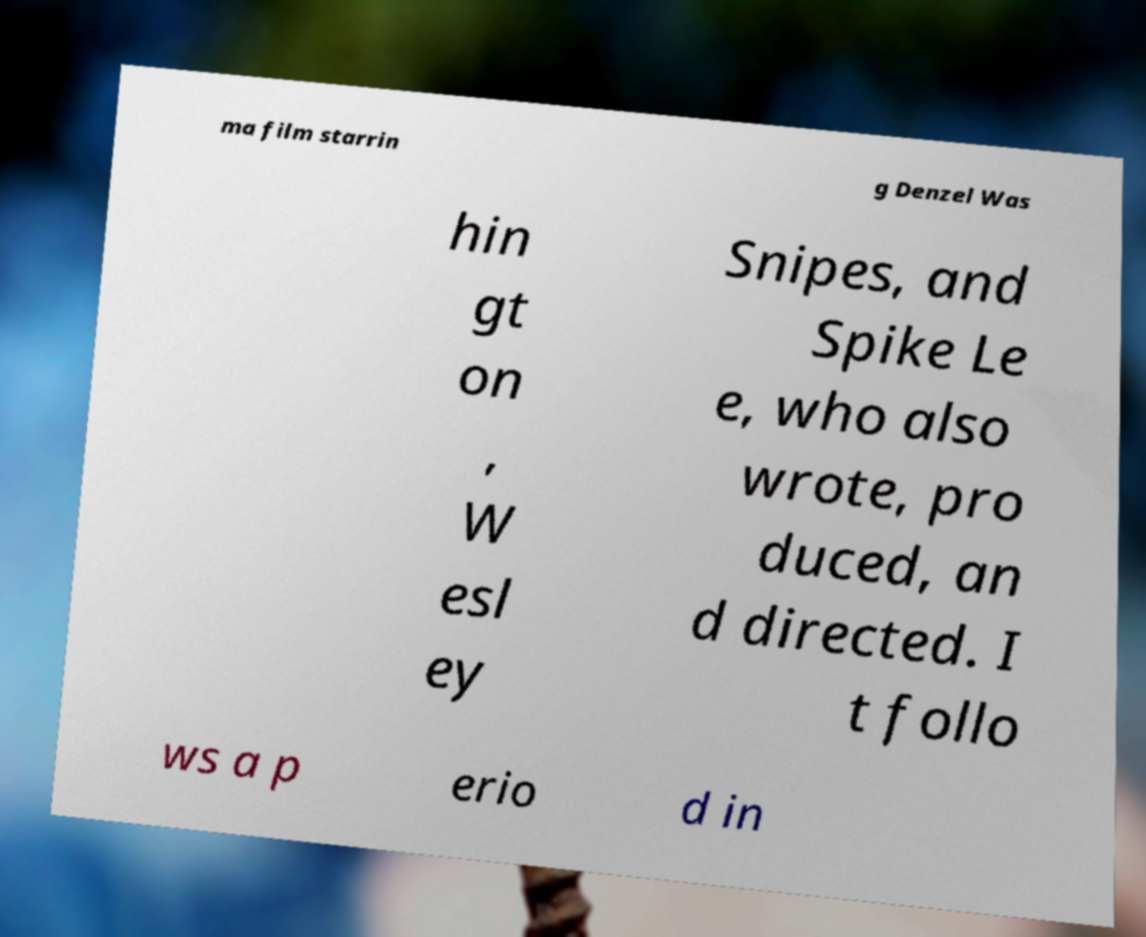Can you read and provide the text displayed in the image?This photo seems to have some interesting text. Can you extract and type it out for me? ma film starrin g Denzel Was hin gt on , W esl ey Snipes, and Spike Le e, who also wrote, pro duced, an d directed. I t follo ws a p erio d in 